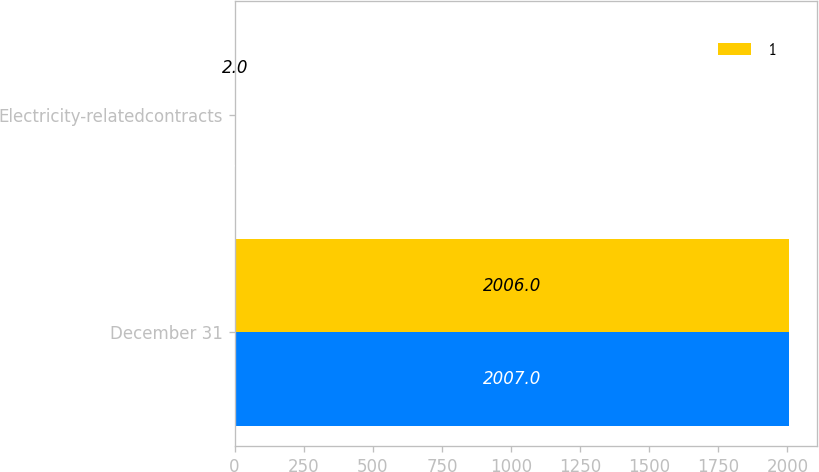<chart> <loc_0><loc_0><loc_500><loc_500><stacked_bar_chart><ecel><fcel>December 31<fcel>Electricity-relatedcontracts<nl><fcel>nan<fcel>2007<fcel>4<nl><fcel>1<fcel>2006<fcel>2<nl></chart> 